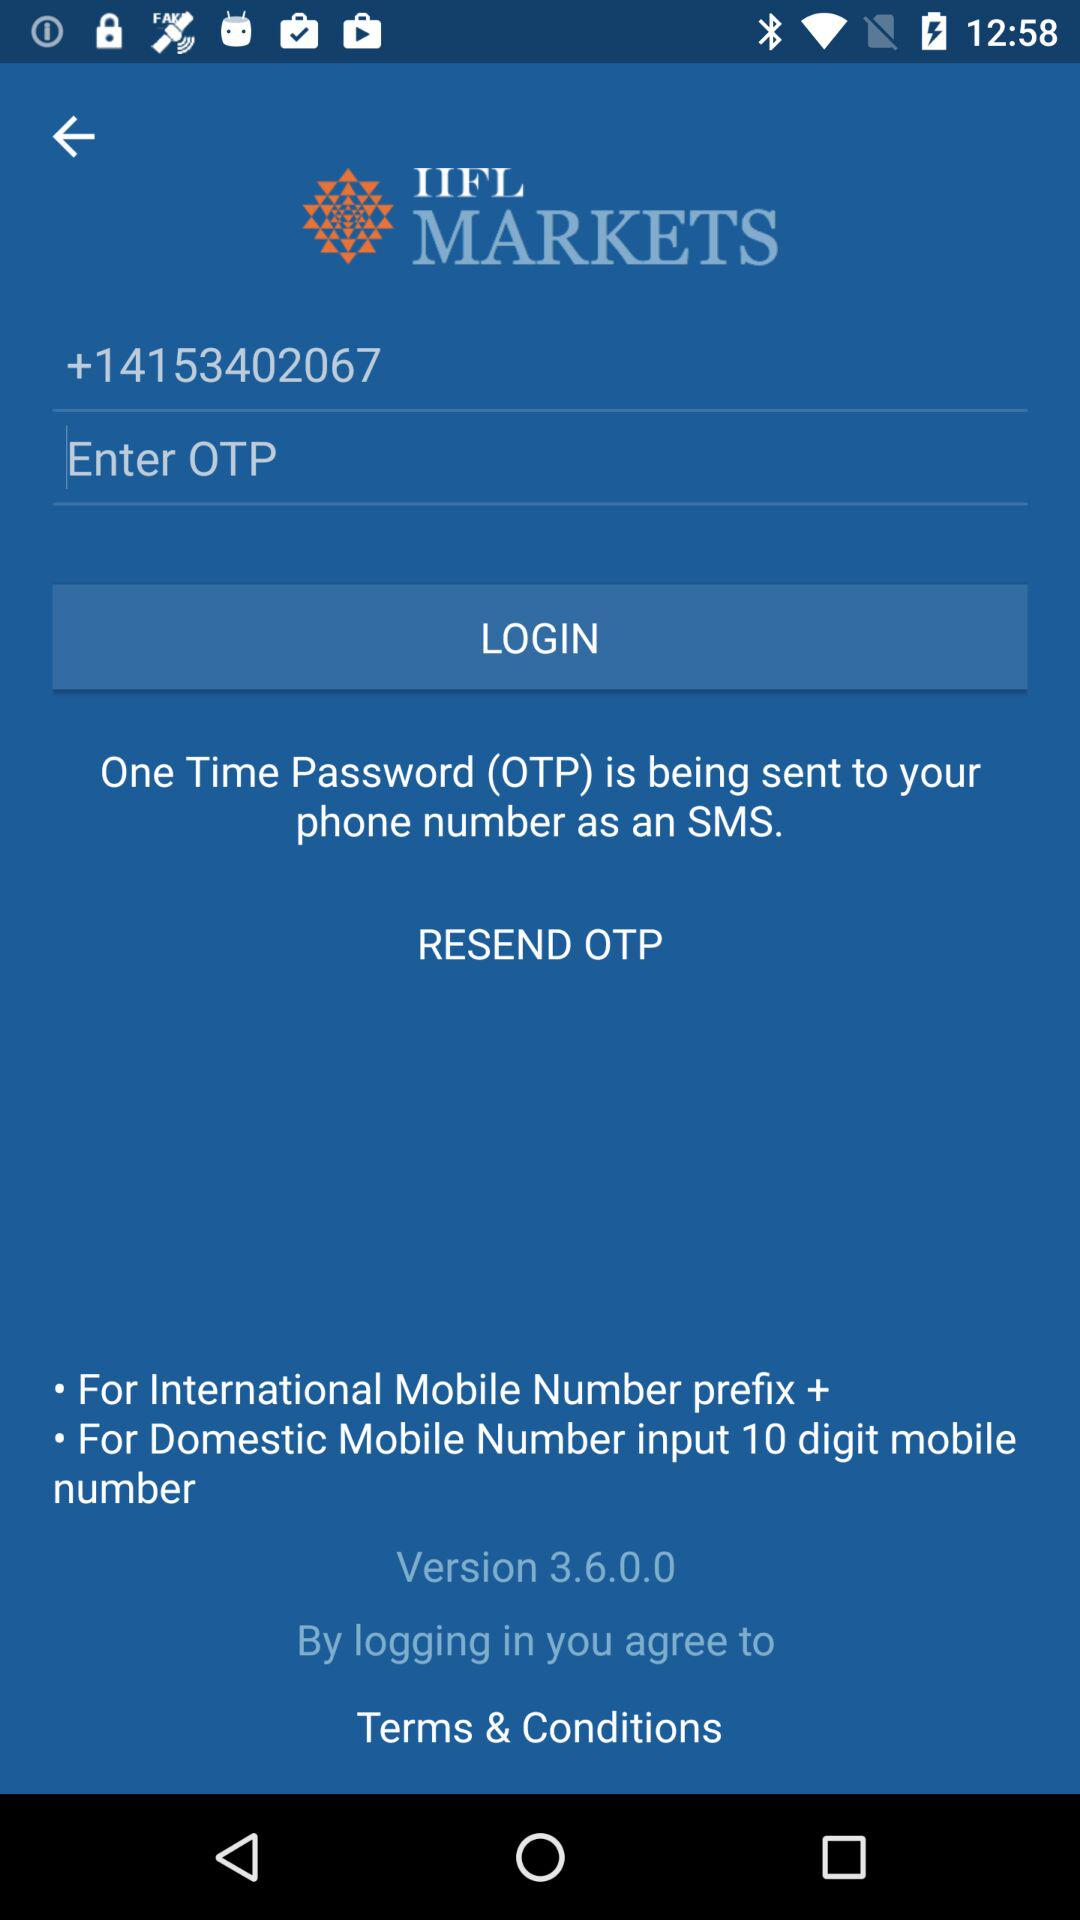What is the version for the IIFL market? The version is 3.6.0.0. 